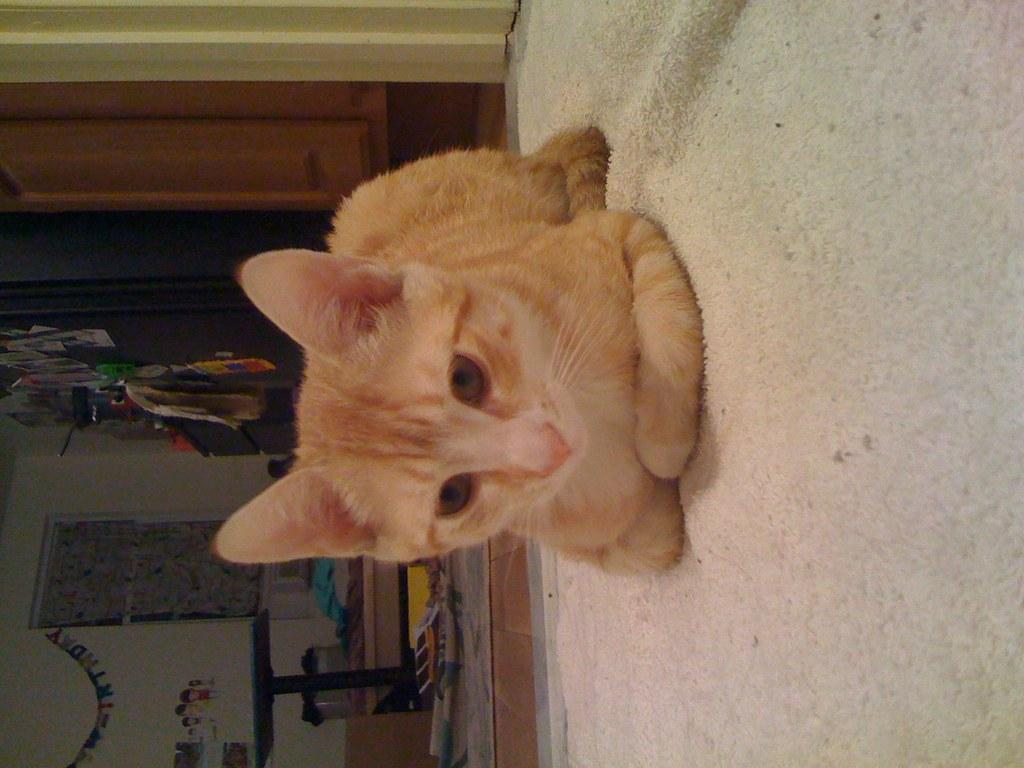What animal is on the cloth in the image? There is a cat on the cloth in the image. What structure is on the left side of the image? There is a table on the left side of the image. What can be found on the table in the image? There are objects on the table in the image. What type of decorations are on the wall in the image? There are decorative items on the wall in the image. How does the cat's mom join the family in the image? There is no mention of the cat's mom or any family members in the image. 